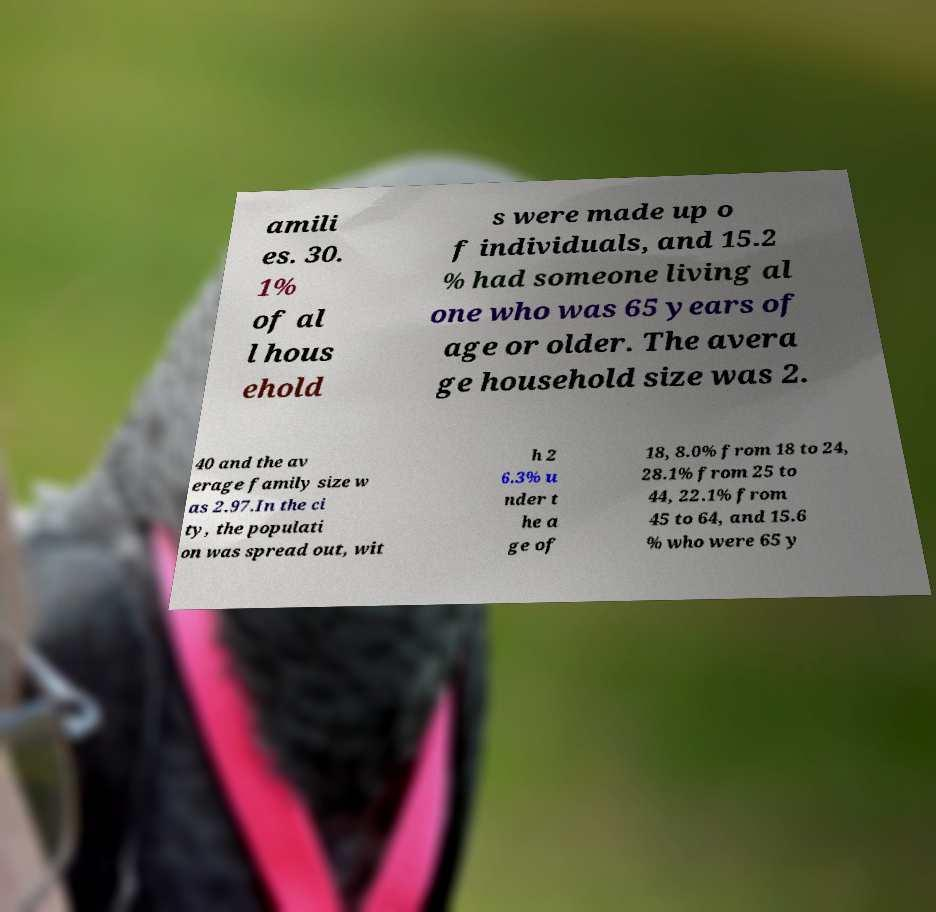Could you assist in decoding the text presented in this image and type it out clearly? amili es. 30. 1% of al l hous ehold s were made up o f individuals, and 15.2 % had someone living al one who was 65 years of age or older. The avera ge household size was 2. 40 and the av erage family size w as 2.97.In the ci ty, the populati on was spread out, wit h 2 6.3% u nder t he a ge of 18, 8.0% from 18 to 24, 28.1% from 25 to 44, 22.1% from 45 to 64, and 15.6 % who were 65 y 